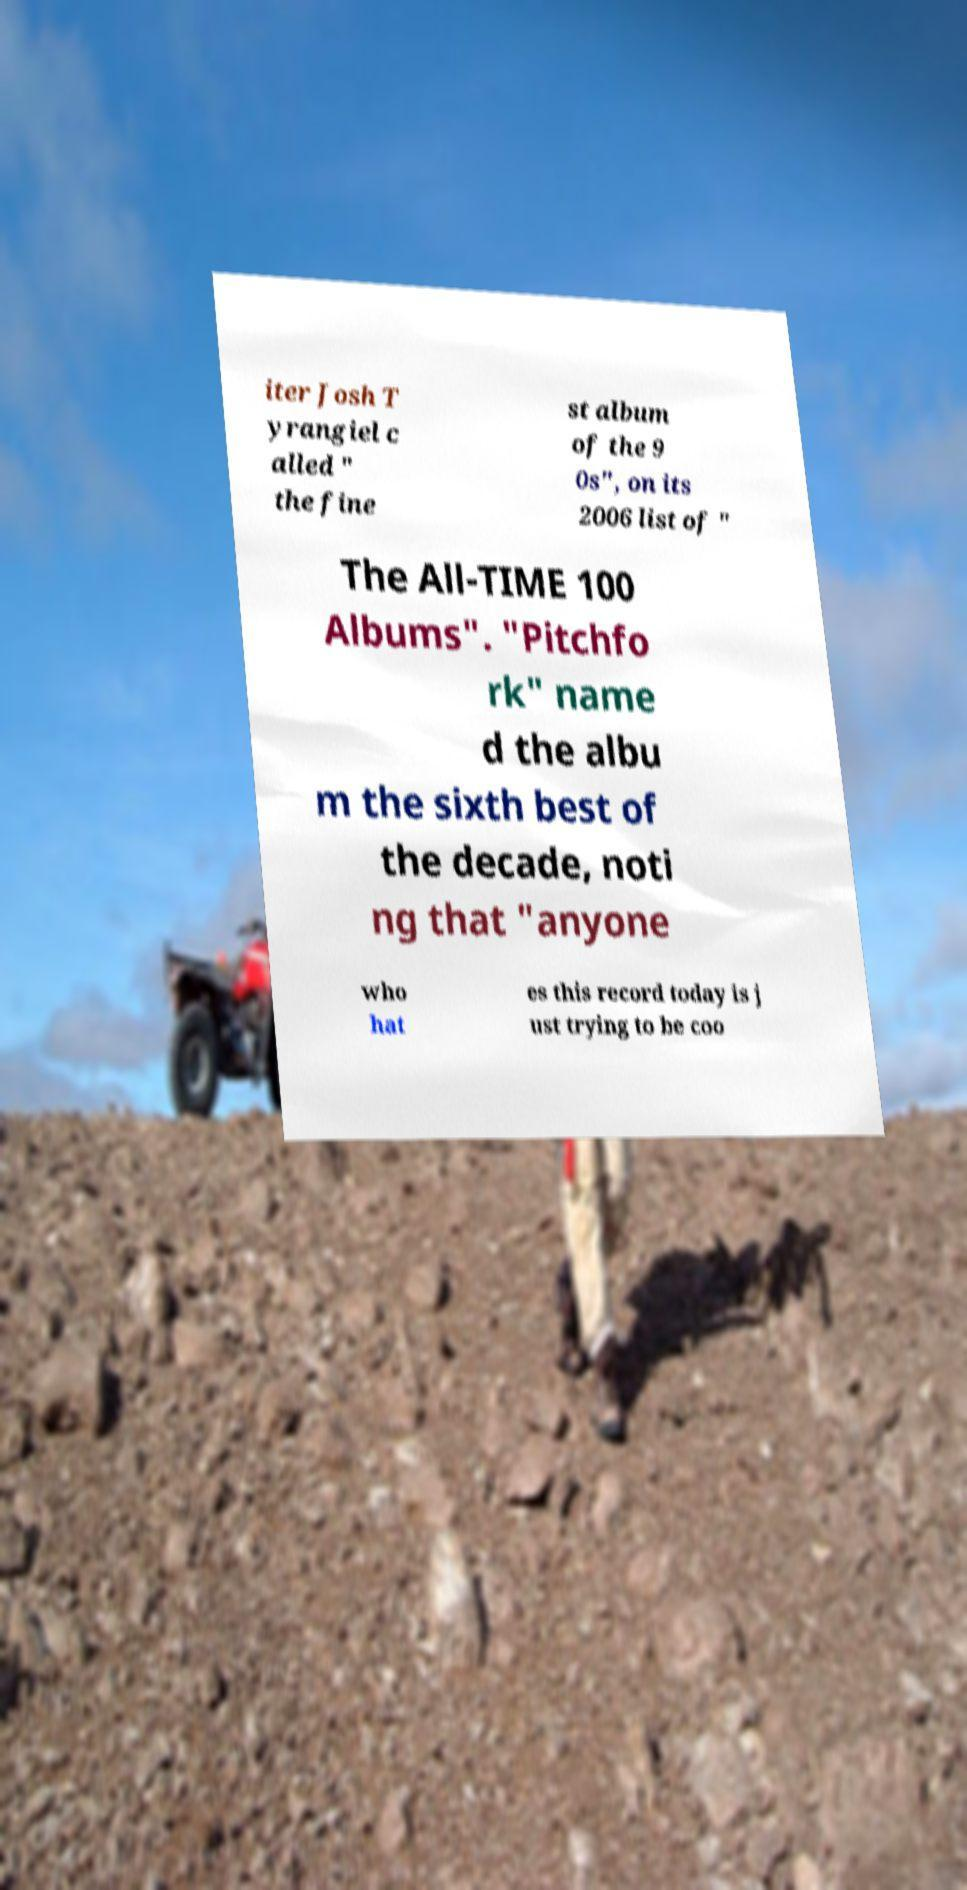There's text embedded in this image that I need extracted. Can you transcribe it verbatim? iter Josh T yrangiel c alled " the fine st album of the 9 0s", on its 2006 list of " The All-TIME 100 Albums". "Pitchfo rk" name d the albu m the sixth best of the decade, noti ng that "anyone who hat es this record today is j ust trying to be coo 